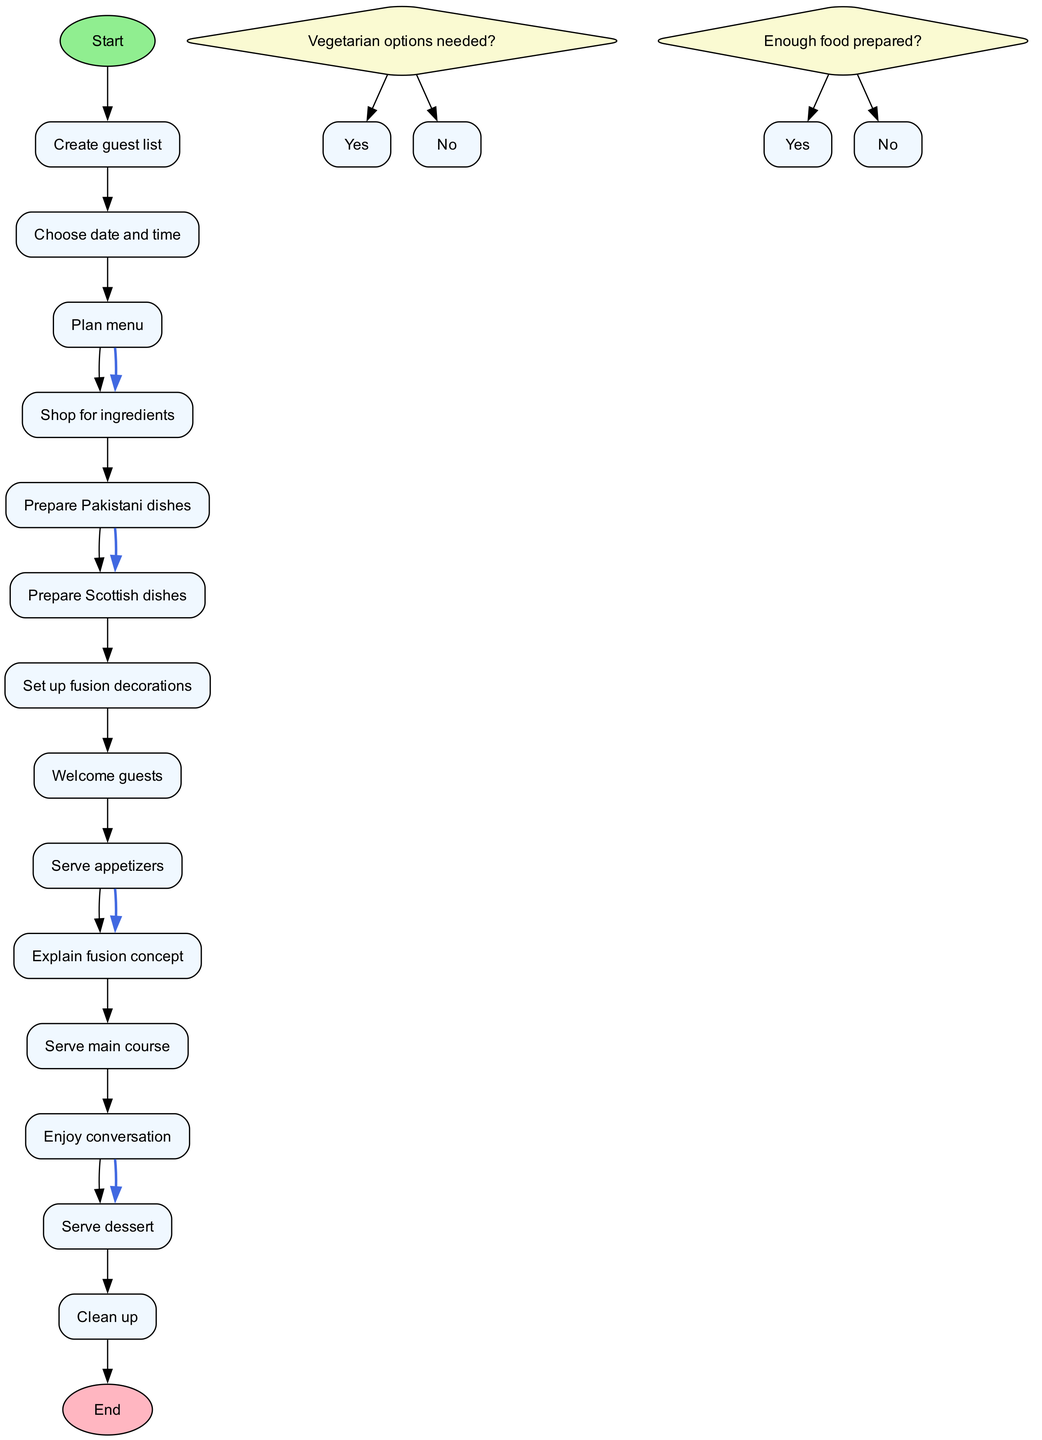What is the starting point of the diagram? The starting point of the diagram is labeled "Begin party planning," as indicated in the start node which initiates the flow of activities.
Answer: Begin party planning How many activities are there in total? By counting the activities listed in the diagram, there are a total of 13 activities included in the flow.
Answer: 13 What is the last activity before guests are served dessert? The activity just before serving dessert is "Enjoy conversation," which indicates a social interaction before the dessert is served to guests.
Answer: Enjoy conversation What decision is made regarding vegetarian options? The diagram includes a decision node that poses the question "Vegetarian options needed?" with "Yes" and "No" as options that guide following decisions in the process.
Answer: Vegetarian options needed? How many flows connect the activities? The diagram has several flows connecting activities, one of which goes from "Prepare Pakistani dishes" to "Prepare Scottish dishes" and others, totaling to 3 specific flows listed in the provided data.
Answer: 3 What happens after welcoming guests? After the "Welcome guests" activity, the next step in the flow is "Serve appetizers," indicating the progression from guest arrival to initial food service.
Answer: Serve appetizers What is the outcome if enough food is prepared? The decision "Enough food prepared?" leads to the next flows of activities, suggesting that if "Yes," the party can continue smoothly without disruptions.
Answer: Yes What marks the end of the dinner party? The final activity that signifies the conclusion of the dinner party process is labeled "End of dinner party" which shows the termination of all activities involved in hosting.
Answer: End of dinner party What activity comes immediately after serving appetizers? "Explain fusion concept" follows the "Serve appetizers" activity, indicating an interactive moment focused on the fusion theme presented at the party.
Answer: Explain fusion concept 